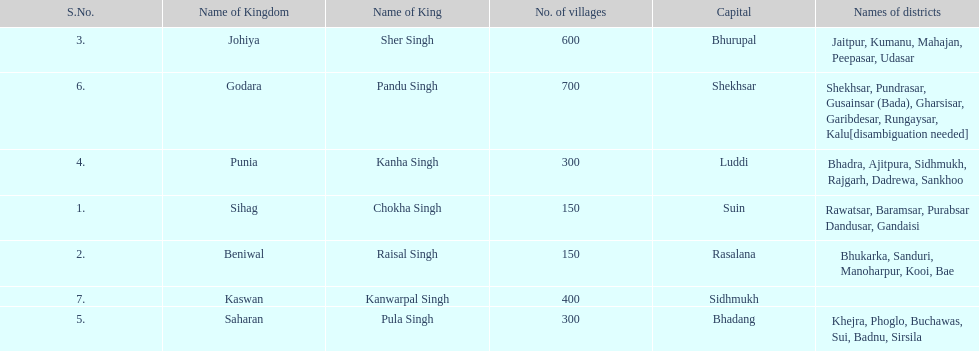What was the total number of districts within the state of godara? 7. Would you mind parsing the complete table? {'header': ['S.No.', 'Name of Kingdom', 'Name of King', 'No. of villages', 'Capital', 'Names of districts'], 'rows': [['3.', 'Johiya', 'Sher Singh', '600', 'Bhurupal', 'Jaitpur, Kumanu, Mahajan, Peepasar, Udasar'], ['6.', 'Godara', 'Pandu Singh', '700', 'Shekhsar', 'Shekhsar, Pundrasar, Gusainsar (Bada), Gharsisar, Garibdesar, Rungaysar, Kalu[disambiguation needed]'], ['4.', 'Punia', 'Kanha Singh', '300', 'Luddi', 'Bhadra, Ajitpura, Sidhmukh, Rajgarh, Dadrewa, Sankhoo'], ['1.', 'Sihag', 'Chokha Singh', '150', 'Suin', 'Rawatsar, Baramsar, Purabsar Dandusar, Gandaisi'], ['2.', 'Beniwal', 'Raisal Singh', '150', 'Rasalana', 'Bhukarka, Sanduri, Manoharpur, Kooi, Bae'], ['7.', 'Kaswan', 'Kanwarpal Singh', '400', 'Sidhmukh', ''], ['5.', 'Saharan', 'Pula Singh', '300', 'Bhadang', 'Khejra, Phoglo, Buchawas, Sui, Badnu, Sirsila']]} 